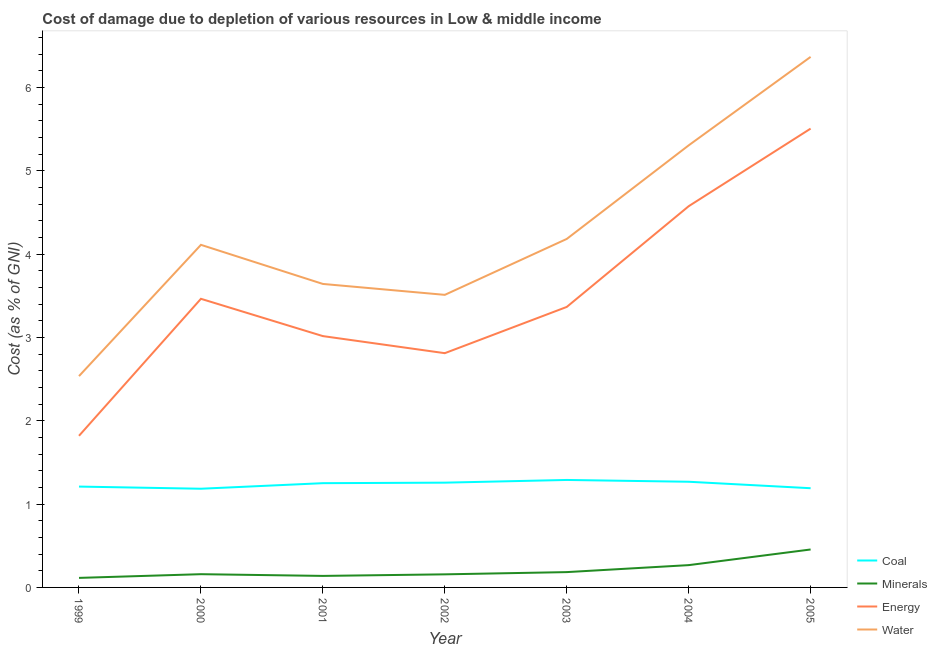How many different coloured lines are there?
Provide a succinct answer. 4. What is the cost of damage due to depletion of energy in 2004?
Give a very brief answer. 4.58. Across all years, what is the maximum cost of damage due to depletion of minerals?
Give a very brief answer. 0.46. Across all years, what is the minimum cost of damage due to depletion of water?
Make the answer very short. 2.54. What is the total cost of damage due to depletion of coal in the graph?
Provide a short and direct response. 8.65. What is the difference between the cost of damage due to depletion of water in 1999 and that in 2003?
Your answer should be very brief. -1.65. What is the difference between the cost of damage due to depletion of energy in 1999 and the cost of damage due to depletion of water in 2003?
Keep it short and to the point. -2.36. What is the average cost of damage due to depletion of minerals per year?
Make the answer very short. 0.21. In the year 2001, what is the difference between the cost of damage due to depletion of coal and cost of damage due to depletion of energy?
Keep it short and to the point. -1.77. In how many years, is the cost of damage due to depletion of minerals greater than 1.4 %?
Provide a short and direct response. 0. What is the ratio of the cost of damage due to depletion of coal in 2000 to that in 2004?
Provide a short and direct response. 0.93. What is the difference between the highest and the second highest cost of damage due to depletion of energy?
Give a very brief answer. 0.93. What is the difference between the highest and the lowest cost of damage due to depletion of minerals?
Offer a very short reply. 0.34. Is the sum of the cost of damage due to depletion of energy in 2000 and 2005 greater than the maximum cost of damage due to depletion of minerals across all years?
Ensure brevity in your answer.  Yes. Is the cost of damage due to depletion of water strictly greater than the cost of damage due to depletion of energy over the years?
Your answer should be compact. Yes. Is the cost of damage due to depletion of energy strictly less than the cost of damage due to depletion of minerals over the years?
Keep it short and to the point. No. How many years are there in the graph?
Ensure brevity in your answer.  7. What is the difference between two consecutive major ticks on the Y-axis?
Make the answer very short. 1. Are the values on the major ticks of Y-axis written in scientific E-notation?
Ensure brevity in your answer.  No. Does the graph contain grids?
Your answer should be compact. No. How many legend labels are there?
Your answer should be very brief. 4. How are the legend labels stacked?
Provide a succinct answer. Vertical. What is the title of the graph?
Make the answer very short. Cost of damage due to depletion of various resources in Low & middle income . Does "WFP" appear as one of the legend labels in the graph?
Ensure brevity in your answer.  No. What is the label or title of the Y-axis?
Provide a succinct answer. Cost (as % of GNI). What is the Cost (as % of GNI) in Coal in 1999?
Offer a very short reply. 1.21. What is the Cost (as % of GNI) of Minerals in 1999?
Give a very brief answer. 0.11. What is the Cost (as % of GNI) of Energy in 1999?
Make the answer very short. 1.82. What is the Cost (as % of GNI) in Water in 1999?
Offer a terse response. 2.54. What is the Cost (as % of GNI) in Coal in 2000?
Provide a short and direct response. 1.18. What is the Cost (as % of GNI) of Minerals in 2000?
Your answer should be very brief. 0.16. What is the Cost (as % of GNI) of Energy in 2000?
Give a very brief answer. 3.46. What is the Cost (as % of GNI) of Water in 2000?
Ensure brevity in your answer.  4.11. What is the Cost (as % of GNI) of Coal in 2001?
Offer a very short reply. 1.25. What is the Cost (as % of GNI) of Minerals in 2001?
Offer a terse response. 0.14. What is the Cost (as % of GNI) in Energy in 2001?
Your answer should be very brief. 3.02. What is the Cost (as % of GNI) in Water in 2001?
Keep it short and to the point. 3.64. What is the Cost (as % of GNI) of Coal in 2002?
Provide a succinct answer. 1.26. What is the Cost (as % of GNI) in Minerals in 2002?
Offer a terse response. 0.16. What is the Cost (as % of GNI) of Energy in 2002?
Provide a succinct answer. 2.81. What is the Cost (as % of GNI) of Water in 2002?
Offer a very short reply. 3.51. What is the Cost (as % of GNI) in Coal in 2003?
Your response must be concise. 1.29. What is the Cost (as % of GNI) in Minerals in 2003?
Make the answer very short. 0.18. What is the Cost (as % of GNI) of Energy in 2003?
Your response must be concise. 3.37. What is the Cost (as % of GNI) in Water in 2003?
Give a very brief answer. 4.18. What is the Cost (as % of GNI) in Coal in 2004?
Your answer should be compact. 1.27. What is the Cost (as % of GNI) of Minerals in 2004?
Keep it short and to the point. 0.27. What is the Cost (as % of GNI) of Energy in 2004?
Your response must be concise. 4.58. What is the Cost (as % of GNI) in Water in 2004?
Provide a succinct answer. 5.31. What is the Cost (as % of GNI) in Coal in 2005?
Offer a terse response. 1.19. What is the Cost (as % of GNI) of Minerals in 2005?
Provide a succinct answer. 0.46. What is the Cost (as % of GNI) in Energy in 2005?
Provide a succinct answer. 5.51. What is the Cost (as % of GNI) of Water in 2005?
Offer a terse response. 6.37. Across all years, what is the maximum Cost (as % of GNI) of Coal?
Keep it short and to the point. 1.29. Across all years, what is the maximum Cost (as % of GNI) of Minerals?
Keep it short and to the point. 0.46. Across all years, what is the maximum Cost (as % of GNI) in Energy?
Offer a very short reply. 5.51. Across all years, what is the maximum Cost (as % of GNI) in Water?
Provide a succinct answer. 6.37. Across all years, what is the minimum Cost (as % of GNI) of Coal?
Offer a very short reply. 1.18. Across all years, what is the minimum Cost (as % of GNI) of Minerals?
Give a very brief answer. 0.11. Across all years, what is the minimum Cost (as % of GNI) in Energy?
Provide a succinct answer. 1.82. Across all years, what is the minimum Cost (as % of GNI) in Water?
Offer a terse response. 2.54. What is the total Cost (as % of GNI) of Coal in the graph?
Give a very brief answer. 8.65. What is the total Cost (as % of GNI) of Minerals in the graph?
Your answer should be very brief. 1.48. What is the total Cost (as % of GNI) in Energy in the graph?
Provide a short and direct response. 24.56. What is the total Cost (as % of GNI) in Water in the graph?
Your answer should be very brief. 29.66. What is the difference between the Cost (as % of GNI) of Coal in 1999 and that in 2000?
Your answer should be compact. 0.03. What is the difference between the Cost (as % of GNI) of Minerals in 1999 and that in 2000?
Keep it short and to the point. -0.04. What is the difference between the Cost (as % of GNI) in Energy in 1999 and that in 2000?
Ensure brevity in your answer.  -1.64. What is the difference between the Cost (as % of GNI) of Water in 1999 and that in 2000?
Make the answer very short. -1.58. What is the difference between the Cost (as % of GNI) of Coal in 1999 and that in 2001?
Offer a very short reply. -0.04. What is the difference between the Cost (as % of GNI) of Minerals in 1999 and that in 2001?
Give a very brief answer. -0.02. What is the difference between the Cost (as % of GNI) of Energy in 1999 and that in 2001?
Provide a succinct answer. -1.2. What is the difference between the Cost (as % of GNI) in Water in 1999 and that in 2001?
Provide a succinct answer. -1.11. What is the difference between the Cost (as % of GNI) in Coal in 1999 and that in 2002?
Ensure brevity in your answer.  -0.05. What is the difference between the Cost (as % of GNI) in Minerals in 1999 and that in 2002?
Give a very brief answer. -0.04. What is the difference between the Cost (as % of GNI) in Energy in 1999 and that in 2002?
Provide a succinct answer. -0.99. What is the difference between the Cost (as % of GNI) of Water in 1999 and that in 2002?
Offer a very short reply. -0.98. What is the difference between the Cost (as % of GNI) in Coal in 1999 and that in 2003?
Provide a succinct answer. -0.08. What is the difference between the Cost (as % of GNI) in Minerals in 1999 and that in 2003?
Keep it short and to the point. -0.07. What is the difference between the Cost (as % of GNI) in Energy in 1999 and that in 2003?
Offer a terse response. -1.55. What is the difference between the Cost (as % of GNI) in Water in 1999 and that in 2003?
Offer a terse response. -1.65. What is the difference between the Cost (as % of GNI) in Coal in 1999 and that in 2004?
Give a very brief answer. -0.06. What is the difference between the Cost (as % of GNI) in Minerals in 1999 and that in 2004?
Your answer should be very brief. -0.15. What is the difference between the Cost (as % of GNI) of Energy in 1999 and that in 2004?
Give a very brief answer. -2.76. What is the difference between the Cost (as % of GNI) of Water in 1999 and that in 2004?
Your answer should be very brief. -2.77. What is the difference between the Cost (as % of GNI) of Coal in 1999 and that in 2005?
Provide a succinct answer. 0.02. What is the difference between the Cost (as % of GNI) in Minerals in 1999 and that in 2005?
Offer a very short reply. -0.34. What is the difference between the Cost (as % of GNI) of Energy in 1999 and that in 2005?
Offer a terse response. -3.69. What is the difference between the Cost (as % of GNI) of Water in 1999 and that in 2005?
Ensure brevity in your answer.  -3.83. What is the difference between the Cost (as % of GNI) in Coal in 2000 and that in 2001?
Provide a succinct answer. -0.07. What is the difference between the Cost (as % of GNI) in Minerals in 2000 and that in 2001?
Provide a succinct answer. 0.02. What is the difference between the Cost (as % of GNI) in Energy in 2000 and that in 2001?
Offer a terse response. 0.45. What is the difference between the Cost (as % of GNI) of Water in 2000 and that in 2001?
Offer a very short reply. 0.47. What is the difference between the Cost (as % of GNI) of Coal in 2000 and that in 2002?
Ensure brevity in your answer.  -0.07. What is the difference between the Cost (as % of GNI) in Minerals in 2000 and that in 2002?
Offer a very short reply. 0. What is the difference between the Cost (as % of GNI) in Energy in 2000 and that in 2002?
Offer a terse response. 0.65. What is the difference between the Cost (as % of GNI) of Water in 2000 and that in 2002?
Keep it short and to the point. 0.6. What is the difference between the Cost (as % of GNI) in Coal in 2000 and that in 2003?
Provide a succinct answer. -0.11. What is the difference between the Cost (as % of GNI) in Minerals in 2000 and that in 2003?
Your answer should be compact. -0.03. What is the difference between the Cost (as % of GNI) of Energy in 2000 and that in 2003?
Give a very brief answer. 0.1. What is the difference between the Cost (as % of GNI) in Water in 2000 and that in 2003?
Ensure brevity in your answer.  -0.07. What is the difference between the Cost (as % of GNI) of Coal in 2000 and that in 2004?
Your answer should be very brief. -0.08. What is the difference between the Cost (as % of GNI) of Minerals in 2000 and that in 2004?
Give a very brief answer. -0.11. What is the difference between the Cost (as % of GNI) in Energy in 2000 and that in 2004?
Offer a terse response. -1.11. What is the difference between the Cost (as % of GNI) in Water in 2000 and that in 2004?
Ensure brevity in your answer.  -1.19. What is the difference between the Cost (as % of GNI) in Coal in 2000 and that in 2005?
Your answer should be very brief. -0.01. What is the difference between the Cost (as % of GNI) in Minerals in 2000 and that in 2005?
Provide a short and direct response. -0.3. What is the difference between the Cost (as % of GNI) of Energy in 2000 and that in 2005?
Ensure brevity in your answer.  -2.04. What is the difference between the Cost (as % of GNI) in Water in 2000 and that in 2005?
Ensure brevity in your answer.  -2.26. What is the difference between the Cost (as % of GNI) of Coal in 2001 and that in 2002?
Provide a short and direct response. -0.01. What is the difference between the Cost (as % of GNI) in Minerals in 2001 and that in 2002?
Your answer should be very brief. -0.02. What is the difference between the Cost (as % of GNI) in Energy in 2001 and that in 2002?
Provide a short and direct response. 0.2. What is the difference between the Cost (as % of GNI) of Water in 2001 and that in 2002?
Make the answer very short. 0.13. What is the difference between the Cost (as % of GNI) in Coal in 2001 and that in 2003?
Your answer should be very brief. -0.04. What is the difference between the Cost (as % of GNI) of Minerals in 2001 and that in 2003?
Provide a short and direct response. -0.05. What is the difference between the Cost (as % of GNI) of Energy in 2001 and that in 2003?
Offer a terse response. -0.35. What is the difference between the Cost (as % of GNI) in Water in 2001 and that in 2003?
Provide a succinct answer. -0.54. What is the difference between the Cost (as % of GNI) in Coal in 2001 and that in 2004?
Make the answer very short. -0.02. What is the difference between the Cost (as % of GNI) in Minerals in 2001 and that in 2004?
Your answer should be compact. -0.13. What is the difference between the Cost (as % of GNI) of Energy in 2001 and that in 2004?
Offer a very short reply. -1.56. What is the difference between the Cost (as % of GNI) of Water in 2001 and that in 2004?
Keep it short and to the point. -1.66. What is the difference between the Cost (as % of GNI) of Coal in 2001 and that in 2005?
Offer a terse response. 0.06. What is the difference between the Cost (as % of GNI) in Minerals in 2001 and that in 2005?
Keep it short and to the point. -0.32. What is the difference between the Cost (as % of GNI) in Energy in 2001 and that in 2005?
Ensure brevity in your answer.  -2.49. What is the difference between the Cost (as % of GNI) of Water in 2001 and that in 2005?
Keep it short and to the point. -2.73. What is the difference between the Cost (as % of GNI) in Coal in 2002 and that in 2003?
Your response must be concise. -0.03. What is the difference between the Cost (as % of GNI) in Minerals in 2002 and that in 2003?
Your answer should be compact. -0.03. What is the difference between the Cost (as % of GNI) in Energy in 2002 and that in 2003?
Provide a succinct answer. -0.55. What is the difference between the Cost (as % of GNI) of Water in 2002 and that in 2003?
Offer a terse response. -0.67. What is the difference between the Cost (as % of GNI) of Coal in 2002 and that in 2004?
Provide a short and direct response. -0.01. What is the difference between the Cost (as % of GNI) in Minerals in 2002 and that in 2004?
Ensure brevity in your answer.  -0.11. What is the difference between the Cost (as % of GNI) of Energy in 2002 and that in 2004?
Offer a very short reply. -1.76. What is the difference between the Cost (as % of GNI) of Water in 2002 and that in 2004?
Your answer should be compact. -1.79. What is the difference between the Cost (as % of GNI) in Coal in 2002 and that in 2005?
Provide a succinct answer. 0.07. What is the difference between the Cost (as % of GNI) of Minerals in 2002 and that in 2005?
Make the answer very short. -0.3. What is the difference between the Cost (as % of GNI) in Energy in 2002 and that in 2005?
Give a very brief answer. -2.7. What is the difference between the Cost (as % of GNI) in Water in 2002 and that in 2005?
Your response must be concise. -2.86. What is the difference between the Cost (as % of GNI) of Coal in 2003 and that in 2004?
Ensure brevity in your answer.  0.02. What is the difference between the Cost (as % of GNI) in Minerals in 2003 and that in 2004?
Your answer should be very brief. -0.08. What is the difference between the Cost (as % of GNI) in Energy in 2003 and that in 2004?
Your answer should be very brief. -1.21. What is the difference between the Cost (as % of GNI) in Water in 2003 and that in 2004?
Your answer should be very brief. -1.12. What is the difference between the Cost (as % of GNI) of Coal in 2003 and that in 2005?
Your answer should be compact. 0.1. What is the difference between the Cost (as % of GNI) in Minerals in 2003 and that in 2005?
Offer a terse response. -0.27. What is the difference between the Cost (as % of GNI) of Energy in 2003 and that in 2005?
Keep it short and to the point. -2.14. What is the difference between the Cost (as % of GNI) of Water in 2003 and that in 2005?
Provide a succinct answer. -2.19. What is the difference between the Cost (as % of GNI) of Coal in 2004 and that in 2005?
Your answer should be very brief. 0.08. What is the difference between the Cost (as % of GNI) of Minerals in 2004 and that in 2005?
Keep it short and to the point. -0.19. What is the difference between the Cost (as % of GNI) of Energy in 2004 and that in 2005?
Ensure brevity in your answer.  -0.93. What is the difference between the Cost (as % of GNI) in Water in 2004 and that in 2005?
Offer a terse response. -1.06. What is the difference between the Cost (as % of GNI) of Coal in 1999 and the Cost (as % of GNI) of Minerals in 2000?
Make the answer very short. 1.05. What is the difference between the Cost (as % of GNI) of Coal in 1999 and the Cost (as % of GNI) of Energy in 2000?
Ensure brevity in your answer.  -2.25. What is the difference between the Cost (as % of GNI) in Coal in 1999 and the Cost (as % of GNI) in Water in 2000?
Provide a succinct answer. -2.9. What is the difference between the Cost (as % of GNI) in Minerals in 1999 and the Cost (as % of GNI) in Energy in 2000?
Provide a short and direct response. -3.35. What is the difference between the Cost (as % of GNI) in Minerals in 1999 and the Cost (as % of GNI) in Water in 2000?
Ensure brevity in your answer.  -4. What is the difference between the Cost (as % of GNI) of Energy in 1999 and the Cost (as % of GNI) of Water in 2000?
Your answer should be very brief. -2.29. What is the difference between the Cost (as % of GNI) of Coal in 1999 and the Cost (as % of GNI) of Minerals in 2001?
Your response must be concise. 1.07. What is the difference between the Cost (as % of GNI) of Coal in 1999 and the Cost (as % of GNI) of Energy in 2001?
Give a very brief answer. -1.81. What is the difference between the Cost (as % of GNI) of Coal in 1999 and the Cost (as % of GNI) of Water in 2001?
Provide a short and direct response. -2.43. What is the difference between the Cost (as % of GNI) in Minerals in 1999 and the Cost (as % of GNI) in Energy in 2001?
Make the answer very short. -2.9. What is the difference between the Cost (as % of GNI) of Minerals in 1999 and the Cost (as % of GNI) of Water in 2001?
Keep it short and to the point. -3.53. What is the difference between the Cost (as % of GNI) in Energy in 1999 and the Cost (as % of GNI) in Water in 2001?
Your answer should be compact. -1.82. What is the difference between the Cost (as % of GNI) in Coal in 1999 and the Cost (as % of GNI) in Minerals in 2002?
Give a very brief answer. 1.05. What is the difference between the Cost (as % of GNI) of Coal in 1999 and the Cost (as % of GNI) of Energy in 2002?
Your answer should be compact. -1.6. What is the difference between the Cost (as % of GNI) in Coal in 1999 and the Cost (as % of GNI) in Water in 2002?
Keep it short and to the point. -2.3. What is the difference between the Cost (as % of GNI) of Minerals in 1999 and the Cost (as % of GNI) of Energy in 2002?
Your answer should be very brief. -2.7. What is the difference between the Cost (as % of GNI) of Minerals in 1999 and the Cost (as % of GNI) of Water in 2002?
Make the answer very short. -3.4. What is the difference between the Cost (as % of GNI) of Energy in 1999 and the Cost (as % of GNI) of Water in 2002?
Your response must be concise. -1.69. What is the difference between the Cost (as % of GNI) in Coal in 1999 and the Cost (as % of GNI) in Minerals in 2003?
Keep it short and to the point. 1.03. What is the difference between the Cost (as % of GNI) of Coal in 1999 and the Cost (as % of GNI) of Energy in 2003?
Offer a very short reply. -2.16. What is the difference between the Cost (as % of GNI) of Coal in 1999 and the Cost (as % of GNI) of Water in 2003?
Offer a terse response. -2.97. What is the difference between the Cost (as % of GNI) in Minerals in 1999 and the Cost (as % of GNI) in Energy in 2003?
Offer a very short reply. -3.25. What is the difference between the Cost (as % of GNI) of Minerals in 1999 and the Cost (as % of GNI) of Water in 2003?
Your answer should be compact. -4.07. What is the difference between the Cost (as % of GNI) of Energy in 1999 and the Cost (as % of GNI) of Water in 2003?
Make the answer very short. -2.36. What is the difference between the Cost (as % of GNI) of Coal in 1999 and the Cost (as % of GNI) of Minerals in 2004?
Your answer should be very brief. 0.94. What is the difference between the Cost (as % of GNI) in Coal in 1999 and the Cost (as % of GNI) in Energy in 2004?
Ensure brevity in your answer.  -3.37. What is the difference between the Cost (as % of GNI) in Coal in 1999 and the Cost (as % of GNI) in Water in 2004?
Your response must be concise. -4.1. What is the difference between the Cost (as % of GNI) in Minerals in 1999 and the Cost (as % of GNI) in Energy in 2004?
Your answer should be very brief. -4.46. What is the difference between the Cost (as % of GNI) of Minerals in 1999 and the Cost (as % of GNI) of Water in 2004?
Offer a very short reply. -5.19. What is the difference between the Cost (as % of GNI) in Energy in 1999 and the Cost (as % of GNI) in Water in 2004?
Your answer should be very brief. -3.49. What is the difference between the Cost (as % of GNI) of Coal in 1999 and the Cost (as % of GNI) of Minerals in 2005?
Offer a very short reply. 0.75. What is the difference between the Cost (as % of GNI) of Coal in 1999 and the Cost (as % of GNI) of Energy in 2005?
Offer a very short reply. -4.3. What is the difference between the Cost (as % of GNI) of Coal in 1999 and the Cost (as % of GNI) of Water in 2005?
Your response must be concise. -5.16. What is the difference between the Cost (as % of GNI) in Minerals in 1999 and the Cost (as % of GNI) in Energy in 2005?
Ensure brevity in your answer.  -5.39. What is the difference between the Cost (as % of GNI) of Minerals in 1999 and the Cost (as % of GNI) of Water in 2005?
Ensure brevity in your answer.  -6.25. What is the difference between the Cost (as % of GNI) in Energy in 1999 and the Cost (as % of GNI) in Water in 2005?
Keep it short and to the point. -4.55. What is the difference between the Cost (as % of GNI) in Coal in 2000 and the Cost (as % of GNI) in Minerals in 2001?
Give a very brief answer. 1.05. What is the difference between the Cost (as % of GNI) in Coal in 2000 and the Cost (as % of GNI) in Energy in 2001?
Give a very brief answer. -1.83. What is the difference between the Cost (as % of GNI) in Coal in 2000 and the Cost (as % of GNI) in Water in 2001?
Your answer should be very brief. -2.46. What is the difference between the Cost (as % of GNI) in Minerals in 2000 and the Cost (as % of GNI) in Energy in 2001?
Make the answer very short. -2.86. What is the difference between the Cost (as % of GNI) in Minerals in 2000 and the Cost (as % of GNI) in Water in 2001?
Offer a very short reply. -3.48. What is the difference between the Cost (as % of GNI) in Energy in 2000 and the Cost (as % of GNI) in Water in 2001?
Offer a very short reply. -0.18. What is the difference between the Cost (as % of GNI) in Coal in 2000 and the Cost (as % of GNI) in Minerals in 2002?
Your answer should be very brief. 1.03. What is the difference between the Cost (as % of GNI) in Coal in 2000 and the Cost (as % of GNI) in Energy in 2002?
Make the answer very short. -1.63. What is the difference between the Cost (as % of GNI) of Coal in 2000 and the Cost (as % of GNI) of Water in 2002?
Offer a terse response. -2.33. What is the difference between the Cost (as % of GNI) of Minerals in 2000 and the Cost (as % of GNI) of Energy in 2002?
Your response must be concise. -2.65. What is the difference between the Cost (as % of GNI) of Minerals in 2000 and the Cost (as % of GNI) of Water in 2002?
Your answer should be compact. -3.35. What is the difference between the Cost (as % of GNI) in Energy in 2000 and the Cost (as % of GNI) in Water in 2002?
Make the answer very short. -0.05. What is the difference between the Cost (as % of GNI) of Coal in 2000 and the Cost (as % of GNI) of Energy in 2003?
Offer a very short reply. -2.18. What is the difference between the Cost (as % of GNI) in Coal in 2000 and the Cost (as % of GNI) in Water in 2003?
Your response must be concise. -3. What is the difference between the Cost (as % of GNI) in Minerals in 2000 and the Cost (as % of GNI) in Energy in 2003?
Offer a terse response. -3.21. What is the difference between the Cost (as % of GNI) of Minerals in 2000 and the Cost (as % of GNI) of Water in 2003?
Keep it short and to the point. -4.02. What is the difference between the Cost (as % of GNI) in Energy in 2000 and the Cost (as % of GNI) in Water in 2003?
Offer a terse response. -0.72. What is the difference between the Cost (as % of GNI) in Coal in 2000 and the Cost (as % of GNI) in Minerals in 2004?
Provide a short and direct response. 0.92. What is the difference between the Cost (as % of GNI) in Coal in 2000 and the Cost (as % of GNI) in Energy in 2004?
Offer a terse response. -3.39. What is the difference between the Cost (as % of GNI) in Coal in 2000 and the Cost (as % of GNI) in Water in 2004?
Your response must be concise. -4.12. What is the difference between the Cost (as % of GNI) in Minerals in 2000 and the Cost (as % of GNI) in Energy in 2004?
Your answer should be compact. -4.42. What is the difference between the Cost (as % of GNI) of Minerals in 2000 and the Cost (as % of GNI) of Water in 2004?
Your response must be concise. -5.15. What is the difference between the Cost (as % of GNI) of Energy in 2000 and the Cost (as % of GNI) of Water in 2004?
Your response must be concise. -1.84. What is the difference between the Cost (as % of GNI) in Coal in 2000 and the Cost (as % of GNI) in Minerals in 2005?
Provide a succinct answer. 0.73. What is the difference between the Cost (as % of GNI) in Coal in 2000 and the Cost (as % of GNI) in Energy in 2005?
Make the answer very short. -4.32. What is the difference between the Cost (as % of GNI) in Coal in 2000 and the Cost (as % of GNI) in Water in 2005?
Offer a very short reply. -5.18. What is the difference between the Cost (as % of GNI) of Minerals in 2000 and the Cost (as % of GNI) of Energy in 2005?
Offer a terse response. -5.35. What is the difference between the Cost (as % of GNI) in Minerals in 2000 and the Cost (as % of GNI) in Water in 2005?
Your answer should be very brief. -6.21. What is the difference between the Cost (as % of GNI) in Energy in 2000 and the Cost (as % of GNI) in Water in 2005?
Offer a terse response. -2.9. What is the difference between the Cost (as % of GNI) in Coal in 2001 and the Cost (as % of GNI) in Minerals in 2002?
Make the answer very short. 1.09. What is the difference between the Cost (as % of GNI) of Coal in 2001 and the Cost (as % of GNI) of Energy in 2002?
Keep it short and to the point. -1.56. What is the difference between the Cost (as % of GNI) in Coal in 2001 and the Cost (as % of GNI) in Water in 2002?
Keep it short and to the point. -2.26. What is the difference between the Cost (as % of GNI) of Minerals in 2001 and the Cost (as % of GNI) of Energy in 2002?
Keep it short and to the point. -2.67. What is the difference between the Cost (as % of GNI) in Minerals in 2001 and the Cost (as % of GNI) in Water in 2002?
Offer a very short reply. -3.37. What is the difference between the Cost (as % of GNI) in Energy in 2001 and the Cost (as % of GNI) in Water in 2002?
Make the answer very short. -0.5. What is the difference between the Cost (as % of GNI) in Coal in 2001 and the Cost (as % of GNI) in Minerals in 2003?
Ensure brevity in your answer.  1.07. What is the difference between the Cost (as % of GNI) of Coal in 2001 and the Cost (as % of GNI) of Energy in 2003?
Your answer should be compact. -2.12. What is the difference between the Cost (as % of GNI) in Coal in 2001 and the Cost (as % of GNI) in Water in 2003?
Offer a very short reply. -2.93. What is the difference between the Cost (as % of GNI) of Minerals in 2001 and the Cost (as % of GNI) of Energy in 2003?
Give a very brief answer. -3.23. What is the difference between the Cost (as % of GNI) in Minerals in 2001 and the Cost (as % of GNI) in Water in 2003?
Your response must be concise. -4.04. What is the difference between the Cost (as % of GNI) in Energy in 2001 and the Cost (as % of GNI) in Water in 2003?
Provide a succinct answer. -1.17. What is the difference between the Cost (as % of GNI) of Coal in 2001 and the Cost (as % of GNI) of Minerals in 2004?
Your answer should be compact. 0.98. What is the difference between the Cost (as % of GNI) in Coal in 2001 and the Cost (as % of GNI) in Energy in 2004?
Provide a short and direct response. -3.32. What is the difference between the Cost (as % of GNI) of Coal in 2001 and the Cost (as % of GNI) of Water in 2004?
Provide a short and direct response. -4.05. What is the difference between the Cost (as % of GNI) of Minerals in 2001 and the Cost (as % of GNI) of Energy in 2004?
Make the answer very short. -4.44. What is the difference between the Cost (as % of GNI) in Minerals in 2001 and the Cost (as % of GNI) in Water in 2004?
Your response must be concise. -5.17. What is the difference between the Cost (as % of GNI) of Energy in 2001 and the Cost (as % of GNI) of Water in 2004?
Give a very brief answer. -2.29. What is the difference between the Cost (as % of GNI) in Coal in 2001 and the Cost (as % of GNI) in Minerals in 2005?
Your answer should be very brief. 0.8. What is the difference between the Cost (as % of GNI) of Coal in 2001 and the Cost (as % of GNI) of Energy in 2005?
Keep it short and to the point. -4.26. What is the difference between the Cost (as % of GNI) in Coal in 2001 and the Cost (as % of GNI) in Water in 2005?
Ensure brevity in your answer.  -5.12. What is the difference between the Cost (as % of GNI) of Minerals in 2001 and the Cost (as % of GNI) of Energy in 2005?
Your answer should be compact. -5.37. What is the difference between the Cost (as % of GNI) of Minerals in 2001 and the Cost (as % of GNI) of Water in 2005?
Keep it short and to the point. -6.23. What is the difference between the Cost (as % of GNI) of Energy in 2001 and the Cost (as % of GNI) of Water in 2005?
Ensure brevity in your answer.  -3.35. What is the difference between the Cost (as % of GNI) in Coal in 2002 and the Cost (as % of GNI) in Minerals in 2003?
Offer a terse response. 1.07. What is the difference between the Cost (as % of GNI) in Coal in 2002 and the Cost (as % of GNI) in Energy in 2003?
Provide a succinct answer. -2.11. What is the difference between the Cost (as % of GNI) in Coal in 2002 and the Cost (as % of GNI) in Water in 2003?
Your answer should be compact. -2.93. What is the difference between the Cost (as % of GNI) in Minerals in 2002 and the Cost (as % of GNI) in Energy in 2003?
Offer a very short reply. -3.21. What is the difference between the Cost (as % of GNI) in Minerals in 2002 and the Cost (as % of GNI) in Water in 2003?
Your answer should be compact. -4.03. What is the difference between the Cost (as % of GNI) in Energy in 2002 and the Cost (as % of GNI) in Water in 2003?
Offer a terse response. -1.37. What is the difference between the Cost (as % of GNI) in Coal in 2002 and the Cost (as % of GNI) in Energy in 2004?
Your answer should be compact. -3.32. What is the difference between the Cost (as % of GNI) of Coal in 2002 and the Cost (as % of GNI) of Water in 2004?
Provide a succinct answer. -4.05. What is the difference between the Cost (as % of GNI) in Minerals in 2002 and the Cost (as % of GNI) in Energy in 2004?
Offer a very short reply. -4.42. What is the difference between the Cost (as % of GNI) in Minerals in 2002 and the Cost (as % of GNI) in Water in 2004?
Your answer should be compact. -5.15. What is the difference between the Cost (as % of GNI) of Energy in 2002 and the Cost (as % of GNI) of Water in 2004?
Provide a succinct answer. -2.49. What is the difference between the Cost (as % of GNI) in Coal in 2002 and the Cost (as % of GNI) in Minerals in 2005?
Provide a short and direct response. 0.8. What is the difference between the Cost (as % of GNI) in Coal in 2002 and the Cost (as % of GNI) in Energy in 2005?
Keep it short and to the point. -4.25. What is the difference between the Cost (as % of GNI) in Coal in 2002 and the Cost (as % of GNI) in Water in 2005?
Make the answer very short. -5.11. What is the difference between the Cost (as % of GNI) in Minerals in 2002 and the Cost (as % of GNI) in Energy in 2005?
Offer a terse response. -5.35. What is the difference between the Cost (as % of GNI) of Minerals in 2002 and the Cost (as % of GNI) of Water in 2005?
Give a very brief answer. -6.21. What is the difference between the Cost (as % of GNI) in Energy in 2002 and the Cost (as % of GNI) in Water in 2005?
Your response must be concise. -3.56. What is the difference between the Cost (as % of GNI) of Coal in 2003 and the Cost (as % of GNI) of Minerals in 2004?
Provide a short and direct response. 1.02. What is the difference between the Cost (as % of GNI) in Coal in 2003 and the Cost (as % of GNI) in Energy in 2004?
Ensure brevity in your answer.  -3.29. What is the difference between the Cost (as % of GNI) in Coal in 2003 and the Cost (as % of GNI) in Water in 2004?
Offer a terse response. -4.02. What is the difference between the Cost (as % of GNI) in Minerals in 2003 and the Cost (as % of GNI) in Energy in 2004?
Your response must be concise. -4.39. What is the difference between the Cost (as % of GNI) in Minerals in 2003 and the Cost (as % of GNI) in Water in 2004?
Your answer should be very brief. -5.12. What is the difference between the Cost (as % of GNI) of Energy in 2003 and the Cost (as % of GNI) of Water in 2004?
Give a very brief answer. -1.94. What is the difference between the Cost (as % of GNI) of Coal in 2003 and the Cost (as % of GNI) of Minerals in 2005?
Keep it short and to the point. 0.83. What is the difference between the Cost (as % of GNI) in Coal in 2003 and the Cost (as % of GNI) in Energy in 2005?
Give a very brief answer. -4.22. What is the difference between the Cost (as % of GNI) of Coal in 2003 and the Cost (as % of GNI) of Water in 2005?
Ensure brevity in your answer.  -5.08. What is the difference between the Cost (as % of GNI) in Minerals in 2003 and the Cost (as % of GNI) in Energy in 2005?
Provide a short and direct response. -5.32. What is the difference between the Cost (as % of GNI) in Minerals in 2003 and the Cost (as % of GNI) in Water in 2005?
Your response must be concise. -6.18. What is the difference between the Cost (as % of GNI) of Energy in 2003 and the Cost (as % of GNI) of Water in 2005?
Offer a terse response. -3. What is the difference between the Cost (as % of GNI) in Coal in 2004 and the Cost (as % of GNI) in Minerals in 2005?
Ensure brevity in your answer.  0.81. What is the difference between the Cost (as % of GNI) of Coal in 2004 and the Cost (as % of GNI) of Energy in 2005?
Provide a short and direct response. -4.24. What is the difference between the Cost (as % of GNI) in Coal in 2004 and the Cost (as % of GNI) in Water in 2005?
Give a very brief answer. -5.1. What is the difference between the Cost (as % of GNI) of Minerals in 2004 and the Cost (as % of GNI) of Energy in 2005?
Offer a terse response. -5.24. What is the difference between the Cost (as % of GNI) of Minerals in 2004 and the Cost (as % of GNI) of Water in 2005?
Your answer should be compact. -6.1. What is the difference between the Cost (as % of GNI) of Energy in 2004 and the Cost (as % of GNI) of Water in 2005?
Give a very brief answer. -1.79. What is the average Cost (as % of GNI) in Coal per year?
Your response must be concise. 1.24. What is the average Cost (as % of GNI) of Minerals per year?
Offer a very short reply. 0.21. What is the average Cost (as % of GNI) in Energy per year?
Keep it short and to the point. 3.51. What is the average Cost (as % of GNI) of Water per year?
Provide a short and direct response. 4.24. In the year 1999, what is the difference between the Cost (as % of GNI) in Coal and Cost (as % of GNI) in Minerals?
Offer a very short reply. 1.1. In the year 1999, what is the difference between the Cost (as % of GNI) of Coal and Cost (as % of GNI) of Energy?
Offer a terse response. -0.61. In the year 1999, what is the difference between the Cost (as % of GNI) of Coal and Cost (as % of GNI) of Water?
Your response must be concise. -1.33. In the year 1999, what is the difference between the Cost (as % of GNI) in Minerals and Cost (as % of GNI) in Energy?
Ensure brevity in your answer.  -1.71. In the year 1999, what is the difference between the Cost (as % of GNI) in Minerals and Cost (as % of GNI) in Water?
Your answer should be compact. -2.42. In the year 1999, what is the difference between the Cost (as % of GNI) of Energy and Cost (as % of GNI) of Water?
Give a very brief answer. -0.72. In the year 2000, what is the difference between the Cost (as % of GNI) in Coal and Cost (as % of GNI) in Minerals?
Make the answer very short. 1.03. In the year 2000, what is the difference between the Cost (as % of GNI) in Coal and Cost (as % of GNI) in Energy?
Your answer should be very brief. -2.28. In the year 2000, what is the difference between the Cost (as % of GNI) of Coal and Cost (as % of GNI) of Water?
Keep it short and to the point. -2.93. In the year 2000, what is the difference between the Cost (as % of GNI) in Minerals and Cost (as % of GNI) in Energy?
Keep it short and to the point. -3.31. In the year 2000, what is the difference between the Cost (as % of GNI) in Minerals and Cost (as % of GNI) in Water?
Ensure brevity in your answer.  -3.95. In the year 2000, what is the difference between the Cost (as % of GNI) in Energy and Cost (as % of GNI) in Water?
Give a very brief answer. -0.65. In the year 2001, what is the difference between the Cost (as % of GNI) in Coal and Cost (as % of GNI) in Minerals?
Offer a terse response. 1.11. In the year 2001, what is the difference between the Cost (as % of GNI) in Coal and Cost (as % of GNI) in Energy?
Offer a very short reply. -1.77. In the year 2001, what is the difference between the Cost (as % of GNI) of Coal and Cost (as % of GNI) of Water?
Your response must be concise. -2.39. In the year 2001, what is the difference between the Cost (as % of GNI) in Minerals and Cost (as % of GNI) in Energy?
Your response must be concise. -2.88. In the year 2001, what is the difference between the Cost (as % of GNI) in Minerals and Cost (as % of GNI) in Water?
Offer a terse response. -3.5. In the year 2001, what is the difference between the Cost (as % of GNI) in Energy and Cost (as % of GNI) in Water?
Give a very brief answer. -0.63. In the year 2002, what is the difference between the Cost (as % of GNI) of Coal and Cost (as % of GNI) of Minerals?
Provide a short and direct response. 1.1. In the year 2002, what is the difference between the Cost (as % of GNI) of Coal and Cost (as % of GNI) of Energy?
Your answer should be very brief. -1.55. In the year 2002, what is the difference between the Cost (as % of GNI) of Coal and Cost (as % of GNI) of Water?
Give a very brief answer. -2.25. In the year 2002, what is the difference between the Cost (as % of GNI) of Minerals and Cost (as % of GNI) of Energy?
Give a very brief answer. -2.65. In the year 2002, what is the difference between the Cost (as % of GNI) in Minerals and Cost (as % of GNI) in Water?
Keep it short and to the point. -3.35. In the year 2002, what is the difference between the Cost (as % of GNI) of Energy and Cost (as % of GNI) of Water?
Offer a very short reply. -0.7. In the year 2003, what is the difference between the Cost (as % of GNI) of Coal and Cost (as % of GNI) of Minerals?
Your answer should be very brief. 1.11. In the year 2003, what is the difference between the Cost (as % of GNI) of Coal and Cost (as % of GNI) of Energy?
Ensure brevity in your answer.  -2.08. In the year 2003, what is the difference between the Cost (as % of GNI) in Coal and Cost (as % of GNI) in Water?
Give a very brief answer. -2.89. In the year 2003, what is the difference between the Cost (as % of GNI) in Minerals and Cost (as % of GNI) in Energy?
Ensure brevity in your answer.  -3.18. In the year 2003, what is the difference between the Cost (as % of GNI) of Minerals and Cost (as % of GNI) of Water?
Keep it short and to the point. -4. In the year 2003, what is the difference between the Cost (as % of GNI) in Energy and Cost (as % of GNI) in Water?
Provide a succinct answer. -0.82. In the year 2004, what is the difference between the Cost (as % of GNI) in Coal and Cost (as % of GNI) in Minerals?
Your answer should be very brief. 1. In the year 2004, what is the difference between the Cost (as % of GNI) in Coal and Cost (as % of GNI) in Energy?
Ensure brevity in your answer.  -3.31. In the year 2004, what is the difference between the Cost (as % of GNI) in Coal and Cost (as % of GNI) in Water?
Keep it short and to the point. -4.04. In the year 2004, what is the difference between the Cost (as % of GNI) in Minerals and Cost (as % of GNI) in Energy?
Offer a terse response. -4.31. In the year 2004, what is the difference between the Cost (as % of GNI) of Minerals and Cost (as % of GNI) of Water?
Keep it short and to the point. -5.04. In the year 2004, what is the difference between the Cost (as % of GNI) of Energy and Cost (as % of GNI) of Water?
Offer a very short reply. -0.73. In the year 2005, what is the difference between the Cost (as % of GNI) of Coal and Cost (as % of GNI) of Minerals?
Give a very brief answer. 0.74. In the year 2005, what is the difference between the Cost (as % of GNI) in Coal and Cost (as % of GNI) in Energy?
Provide a succinct answer. -4.32. In the year 2005, what is the difference between the Cost (as % of GNI) in Coal and Cost (as % of GNI) in Water?
Give a very brief answer. -5.18. In the year 2005, what is the difference between the Cost (as % of GNI) of Minerals and Cost (as % of GNI) of Energy?
Make the answer very short. -5.05. In the year 2005, what is the difference between the Cost (as % of GNI) of Minerals and Cost (as % of GNI) of Water?
Keep it short and to the point. -5.91. In the year 2005, what is the difference between the Cost (as % of GNI) of Energy and Cost (as % of GNI) of Water?
Offer a terse response. -0.86. What is the ratio of the Cost (as % of GNI) of Coal in 1999 to that in 2000?
Your answer should be compact. 1.02. What is the ratio of the Cost (as % of GNI) of Minerals in 1999 to that in 2000?
Give a very brief answer. 0.72. What is the ratio of the Cost (as % of GNI) in Energy in 1999 to that in 2000?
Keep it short and to the point. 0.53. What is the ratio of the Cost (as % of GNI) in Water in 1999 to that in 2000?
Offer a very short reply. 0.62. What is the ratio of the Cost (as % of GNI) of Coal in 1999 to that in 2001?
Offer a terse response. 0.97. What is the ratio of the Cost (as % of GNI) in Minerals in 1999 to that in 2001?
Keep it short and to the point. 0.83. What is the ratio of the Cost (as % of GNI) of Energy in 1999 to that in 2001?
Keep it short and to the point. 0.6. What is the ratio of the Cost (as % of GNI) of Water in 1999 to that in 2001?
Offer a terse response. 0.7. What is the ratio of the Cost (as % of GNI) of Coal in 1999 to that in 2002?
Provide a short and direct response. 0.96. What is the ratio of the Cost (as % of GNI) of Minerals in 1999 to that in 2002?
Keep it short and to the point. 0.73. What is the ratio of the Cost (as % of GNI) in Energy in 1999 to that in 2002?
Give a very brief answer. 0.65. What is the ratio of the Cost (as % of GNI) of Water in 1999 to that in 2002?
Your response must be concise. 0.72. What is the ratio of the Cost (as % of GNI) of Coal in 1999 to that in 2003?
Give a very brief answer. 0.94. What is the ratio of the Cost (as % of GNI) in Minerals in 1999 to that in 2003?
Offer a very short reply. 0.62. What is the ratio of the Cost (as % of GNI) of Energy in 1999 to that in 2003?
Provide a short and direct response. 0.54. What is the ratio of the Cost (as % of GNI) in Water in 1999 to that in 2003?
Make the answer very short. 0.61. What is the ratio of the Cost (as % of GNI) in Coal in 1999 to that in 2004?
Offer a terse response. 0.95. What is the ratio of the Cost (as % of GNI) in Minerals in 1999 to that in 2004?
Your response must be concise. 0.43. What is the ratio of the Cost (as % of GNI) in Energy in 1999 to that in 2004?
Keep it short and to the point. 0.4. What is the ratio of the Cost (as % of GNI) in Water in 1999 to that in 2004?
Give a very brief answer. 0.48. What is the ratio of the Cost (as % of GNI) of Coal in 1999 to that in 2005?
Offer a very short reply. 1.02. What is the ratio of the Cost (as % of GNI) of Minerals in 1999 to that in 2005?
Provide a succinct answer. 0.25. What is the ratio of the Cost (as % of GNI) in Energy in 1999 to that in 2005?
Provide a short and direct response. 0.33. What is the ratio of the Cost (as % of GNI) of Water in 1999 to that in 2005?
Make the answer very short. 0.4. What is the ratio of the Cost (as % of GNI) in Coal in 2000 to that in 2001?
Offer a very short reply. 0.95. What is the ratio of the Cost (as % of GNI) of Minerals in 2000 to that in 2001?
Provide a succinct answer. 1.15. What is the ratio of the Cost (as % of GNI) in Energy in 2000 to that in 2001?
Ensure brevity in your answer.  1.15. What is the ratio of the Cost (as % of GNI) in Water in 2000 to that in 2001?
Ensure brevity in your answer.  1.13. What is the ratio of the Cost (as % of GNI) of Coal in 2000 to that in 2002?
Keep it short and to the point. 0.94. What is the ratio of the Cost (as % of GNI) of Minerals in 2000 to that in 2002?
Offer a terse response. 1.01. What is the ratio of the Cost (as % of GNI) in Energy in 2000 to that in 2002?
Provide a succinct answer. 1.23. What is the ratio of the Cost (as % of GNI) in Water in 2000 to that in 2002?
Offer a terse response. 1.17. What is the ratio of the Cost (as % of GNI) of Coal in 2000 to that in 2003?
Your answer should be very brief. 0.92. What is the ratio of the Cost (as % of GNI) in Minerals in 2000 to that in 2003?
Offer a terse response. 0.86. What is the ratio of the Cost (as % of GNI) of Energy in 2000 to that in 2003?
Make the answer very short. 1.03. What is the ratio of the Cost (as % of GNI) in Water in 2000 to that in 2003?
Your answer should be very brief. 0.98. What is the ratio of the Cost (as % of GNI) of Coal in 2000 to that in 2004?
Ensure brevity in your answer.  0.93. What is the ratio of the Cost (as % of GNI) in Minerals in 2000 to that in 2004?
Keep it short and to the point. 0.59. What is the ratio of the Cost (as % of GNI) in Energy in 2000 to that in 2004?
Provide a short and direct response. 0.76. What is the ratio of the Cost (as % of GNI) in Water in 2000 to that in 2004?
Your answer should be very brief. 0.78. What is the ratio of the Cost (as % of GNI) of Minerals in 2000 to that in 2005?
Provide a short and direct response. 0.35. What is the ratio of the Cost (as % of GNI) in Energy in 2000 to that in 2005?
Provide a short and direct response. 0.63. What is the ratio of the Cost (as % of GNI) in Water in 2000 to that in 2005?
Provide a succinct answer. 0.65. What is the ratio of the Cost (as % of GNI) in Coal in 2001 to that in 2002?
Your answer should be compact. 1. What is the ratio of the Cost (as % of GNI) of Minerals in 2001 to that in 2002?
Your answer should be compact. 0.88. What is the ratio of the Cost (as % of GNI) of Energy in 2001 to that in 2002?
Ensure brevity in your answer.  1.07. What is the ratio of the Cost (as % of GNI) of Water in 2001 to that in 2002?
Give a very brief answer. 1.04. What is the ratio of the Cost (as % of GNI) in Coal in 2001 to that in 2003?
Ensure brevity in your answer.  0.97. What is the ratio of the Cost (as % of GNI) of Minerals in 2001 to that in 2003?
Keep it short and to the point. 0.75. What is the ratio of the Cost (as % of GNI) of Energy in 2001 to that in 2003?
Your answer should be very brief. 0.9. What is the ratio of the Cost (as % of GNI) in Water in 2001 to that in 2003?
Make the answer very short. 0.87. What is the ratio of the Cost (as % of GNI) of Coal in 2001 to that in 2004?
Your response must be concise. 0.99. What is the ratio of the Cost (as % of GNI) of Minerals in 2001 to that in 2004?
Provide a succinct answer. 0.52. What is the ratio of the Cost (as % of GNI) in Energy in 2001 to that in 2004?
Make the answer very short. 0.66. What is the ratio of the Cost (as % of GNI) of Water in 2001 to that in 2004?
Offer a very short reply. 0.69. What is the ratio of the Cost (as % of GNI) of Coal in 2001 to that in 2005?
Give a very brief answer. 1.05. What is the ratio of the Cost (as % of GNI) in Minerals in 2001 to that in 2005?
Offer a terse response. 0.3. What is the ratio of the Cost (as % of GNI) in Energy in 2001 to that in 2005?
Keep it short and to the point. 0.55. What is the ratio of the Cost (as % of GNI) of Water in 2001 to that in 2005?
Make the answer very short. 0.57. What is the ratio of the Cost (as % of GNI) of Coal in 2002 to that in 2003?
Make the answer very short. 0.97. What is the ratio of the Cost (as % of GNI) of Minerals in 2002 to that in 2003?
Keep it short and to the point. 0.85. What is the ratio of the Cost (as % of GNI) of Energy in 2002 to that in 2003?
Your answer should be compact. 0.84. What is the ratio of the Cost (as % of GNI) in Water in 2002 to that in 2003?
Provide a short and direct response. 0.84. What is the ratio of the Cost (as % of GNI) in Minerals in 2002 to that in 2004?
Give a very brief answer. 0.59. What is the ratio of the Cost (as % of GNI) in Energy in 2002 to that in 2004?
Your answer should be very brief. 0.61. What is the ratio of the Cost (as % of GNI) of Water in 2002 to that in 2004?
Offer a terse response. 0.66. What is the ratio of the Cost (as % of GNI) of Coal in 2002 to that in 2005?
Your answer should be very brief. 1.06. What is the ratio of the Cost (as % of GNI) in Minerals in 2002 to that in 2005?
Give a very brief answer. 0.34. What is the ratio of the Cost (as % of GNI) in Energy in 2002 to that in 2005?
Ensure brevity in your answer.  0.51. What is the ratio of the Cost (as % of GNI) of Water in 2002 to that in 2005?
Your answer should be very brief. 0.55. What is the ratio of the Cost (as % of GNI) in Minerals in 2003 to that in 2004?
Your answer should be very brief. 0.69. What is the ratio of the Cost (as % of GNI) in Energy in 2003 to that in 2004?
Offer a very short reply. 0.74. What is the ratio of the Cost (as % of GNI) of Water in 2003 to that in 2004?
Ensure brevity in your answer.  0.79. What is the ratio of the Cost (as % of GNI) in Minerals in 2003 to that in 2005?
Offer a terse response. 0.4. What is the ratio of the Cost (as % of GNI) in Energy in 2003 to that in 2005?
Your response must be concise. 0.61. What is the ratio of the Cost (as % of GNI) of Water in 2003 to that in 2005?
Offer a terse response. 0.66. What is the ratio of the Cost (as % of GNI) in Coal in 2004 to that in 2005?
Offer a terse response. 1.07. What is the ratio of the Cost (as % of GNI) in Minerals in 2004 to that in 2005?
Provide a short and direct response. 0.59. What is the ratio of the Cost (as % of GNI) in Energy in 2004 to that in 2005?
Your answer should be compact. 0.83. What is the ratio of the Cost (as % of GNI) of Water in 2004 to that in 2005?
Your answer should be compact. 0.83. What is the difference between the highest and the second highest Cost (as % of GNI) of Coal?
Keep it short and to the point. 0.02. What is the difference between the highest and the second highest Cost (as % of GNI) in Minerals?
Provide a short and direct response. 0.19. What is the difference between the highest and the second highest Cost (as % of GNI) of Energy?
Offer a terse response. 0.93. What is the difference between the highest and the second highest Cost (as % of GNI) of Water?
Keep it short and to the point. 1.06. What is the difference between the highest and the lowest Cost (as % of GNI) in Coal?
Offer a very short reply. 0.11. What is the difference between the highest and the lowest Cost (as % of GNI) of Minerals?
Provide a succinct answer. 0.34. What is the difference between the highest and the lowest Cost (as % of GNI) in Energy?
Your answer should be very brief. 3.69. What is the difference between the highest and the lowest Cost (as % of GNI) in Water?
Provide a short and direct response. 3.83. 